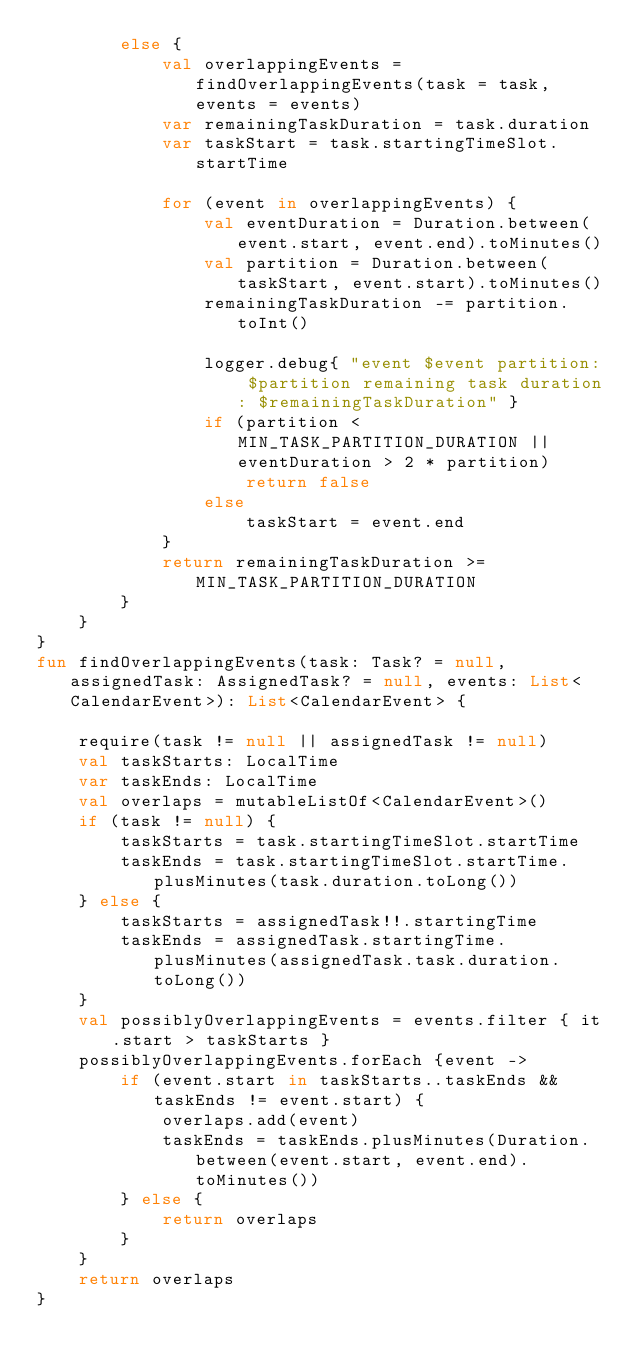Convert code to text. <code><loc_0><loc_0><loc_500><loc_500><_Kotlin_>        else {
            val overlappingEvents = findOverlappingEvents(task = task, events = events)
            var remainingTaskDuration = task.duration
            var taskStart = task.startingTimeSlot.startTime

            for (event in overlappingEvents) {
                val eventDuration = Duration.between(event.start, event.end).toMinutes()
                val partition = Duration.between(taskStart, event.start).toMinutes()
                remainingTaskDuration -= partition.toInt()

                logger.debug{ "event $event partition: $partition remaining task duration: $remainingTaskDuration" }
                if (partition < MIN_TASK_PARTITION_DURATION || eventDuration > 2 * partition)
                    return false
                else
                    taskStart = event.end
            }
            return remainingTaskDuration >= MIN_TASK_PARTITION_DURATION
        }
    }
}
fun findOverlappingEvents(task: Task? = null, assignedTask: AssignedTask? = null, events: List<CalendarEvent>): List<CalendarEvent> {

    require(task != null || assignedTask != null)
    val taskStarts: LocalTime
    var taskEnds: LocalTime
    val overlaps = mutableListOf<CalendarEvent>()
    if (task != null) {
        taskStarts = task.startingTimeSlot.startTime
        taskEnds = task.startingTimeSlot.startTime.plusMinutes(task.duration.toLong())
    } else {
        taskStarts = assignedTask!!.startingTime
        taskEnds = assignedTask.startingTime.plusMinutes(assignedTask.task.duration.toLong())
    }
    val possiblyOverlappingEvents = events.filter { it.start > taskStarts }
    possiblyOverlappingEvents.forEach {event ->
        if (event.start in taskStarts..taskEnds && taskEnds != event.start) {
            overlaps.add(event)
            taskEnds = taskEnds.plusMinutes(Duration.between(event.start, event.end).toMinutes())
        } else {
            return overlaps
        }
    }
    return overlaps
}</code> 